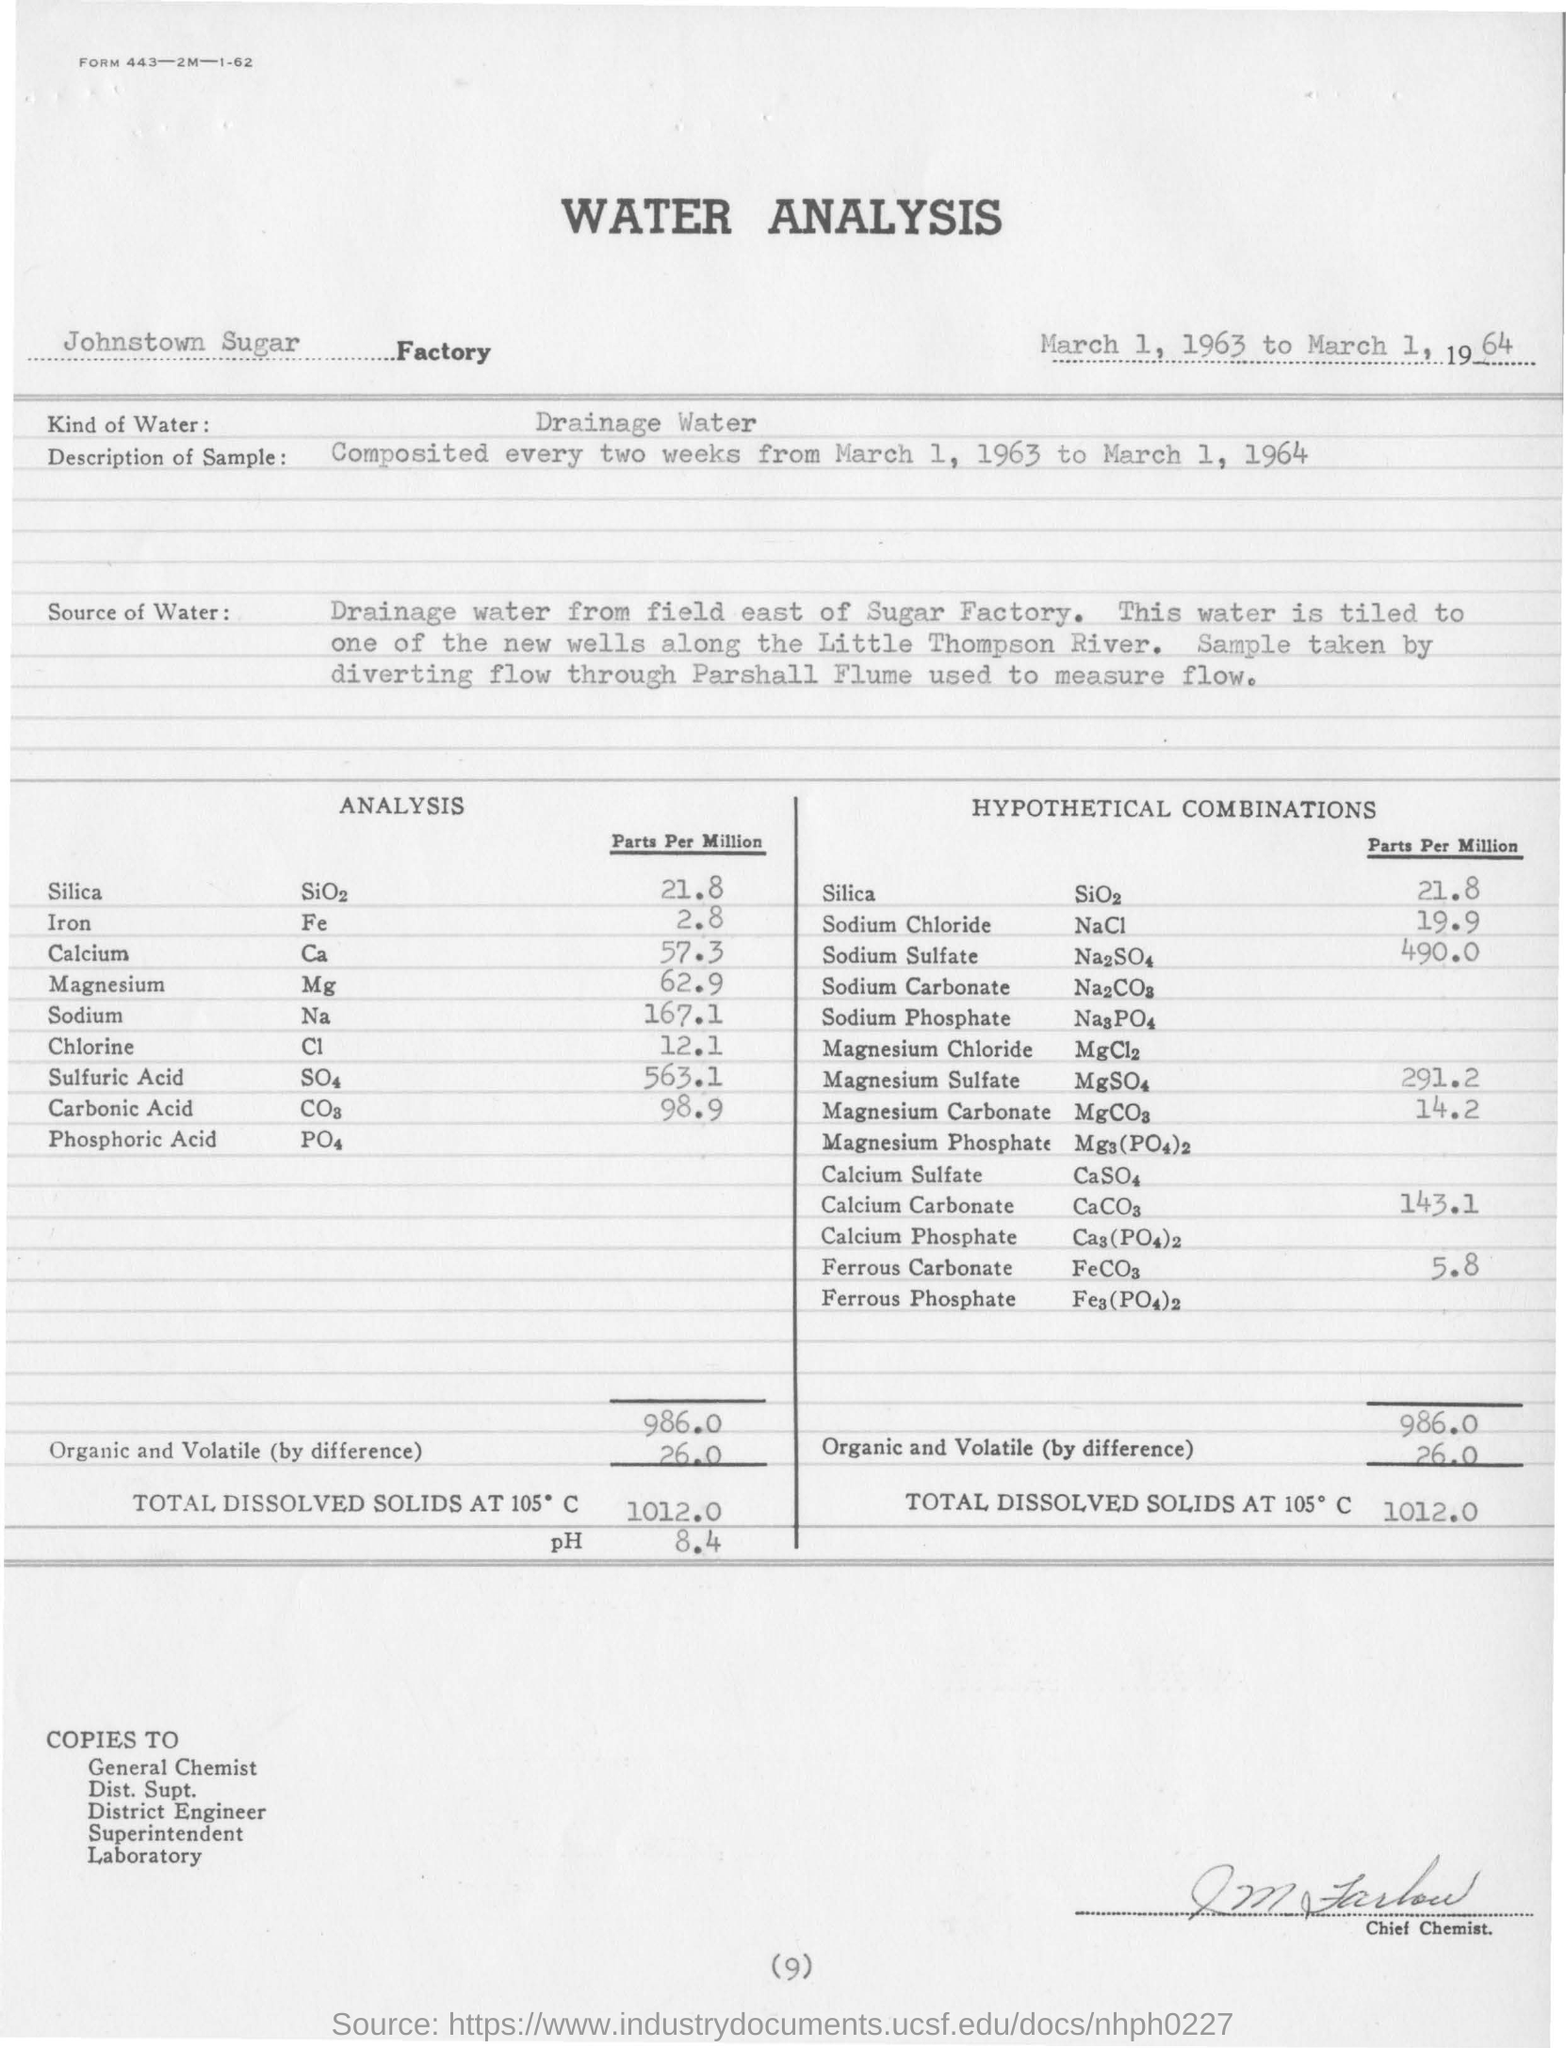Mention a couple of crucial points in this snapshot. The analysis is being done at the Johnstown sugar factory. The type of water used in the analysis is drainage water. 